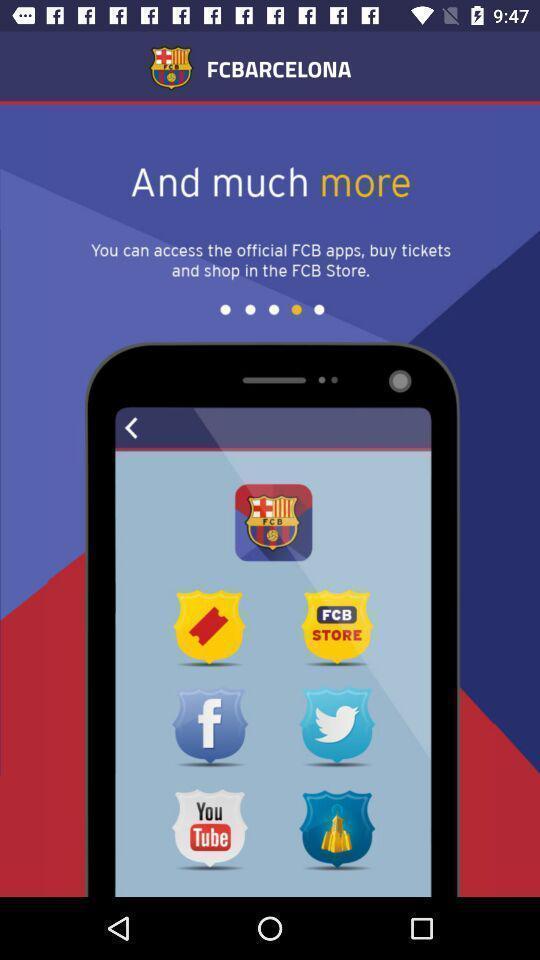Provide a description of this screenshot. Screen displaying the welcome page of sports app. 